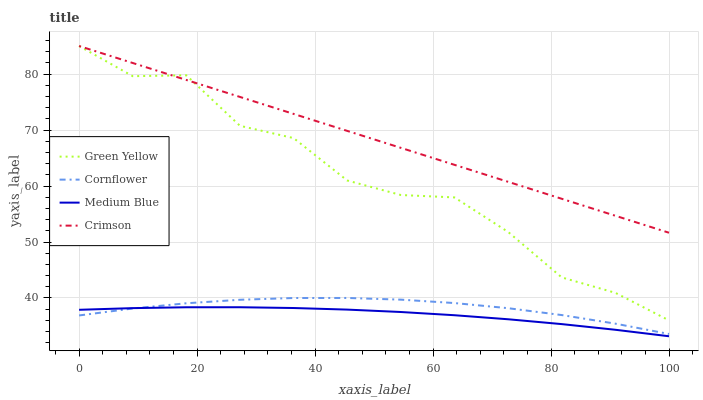Does Cornflower have the minimum area under the curve?
Answer yes or no. No. Does Cornflower have the maximum area under the curve?
Answer yes or no. No. Is Cornflower the smoothest?
Answer yes or no. No. Is Cornflower the roughest?
Answer yes or no. No. Does Cornflower have the lowest value?
Answer yes or no. No. Does Cornflower have the highest value?
Answer yes or no. No. Is Medium Blue less than Crimson?
Answer yes or no. Yes. Is Crimson greater than Medium Blue?
Answer yes or no. Yes. Does Medium Blue intersect Crimson?
Answer yes or no. No. 